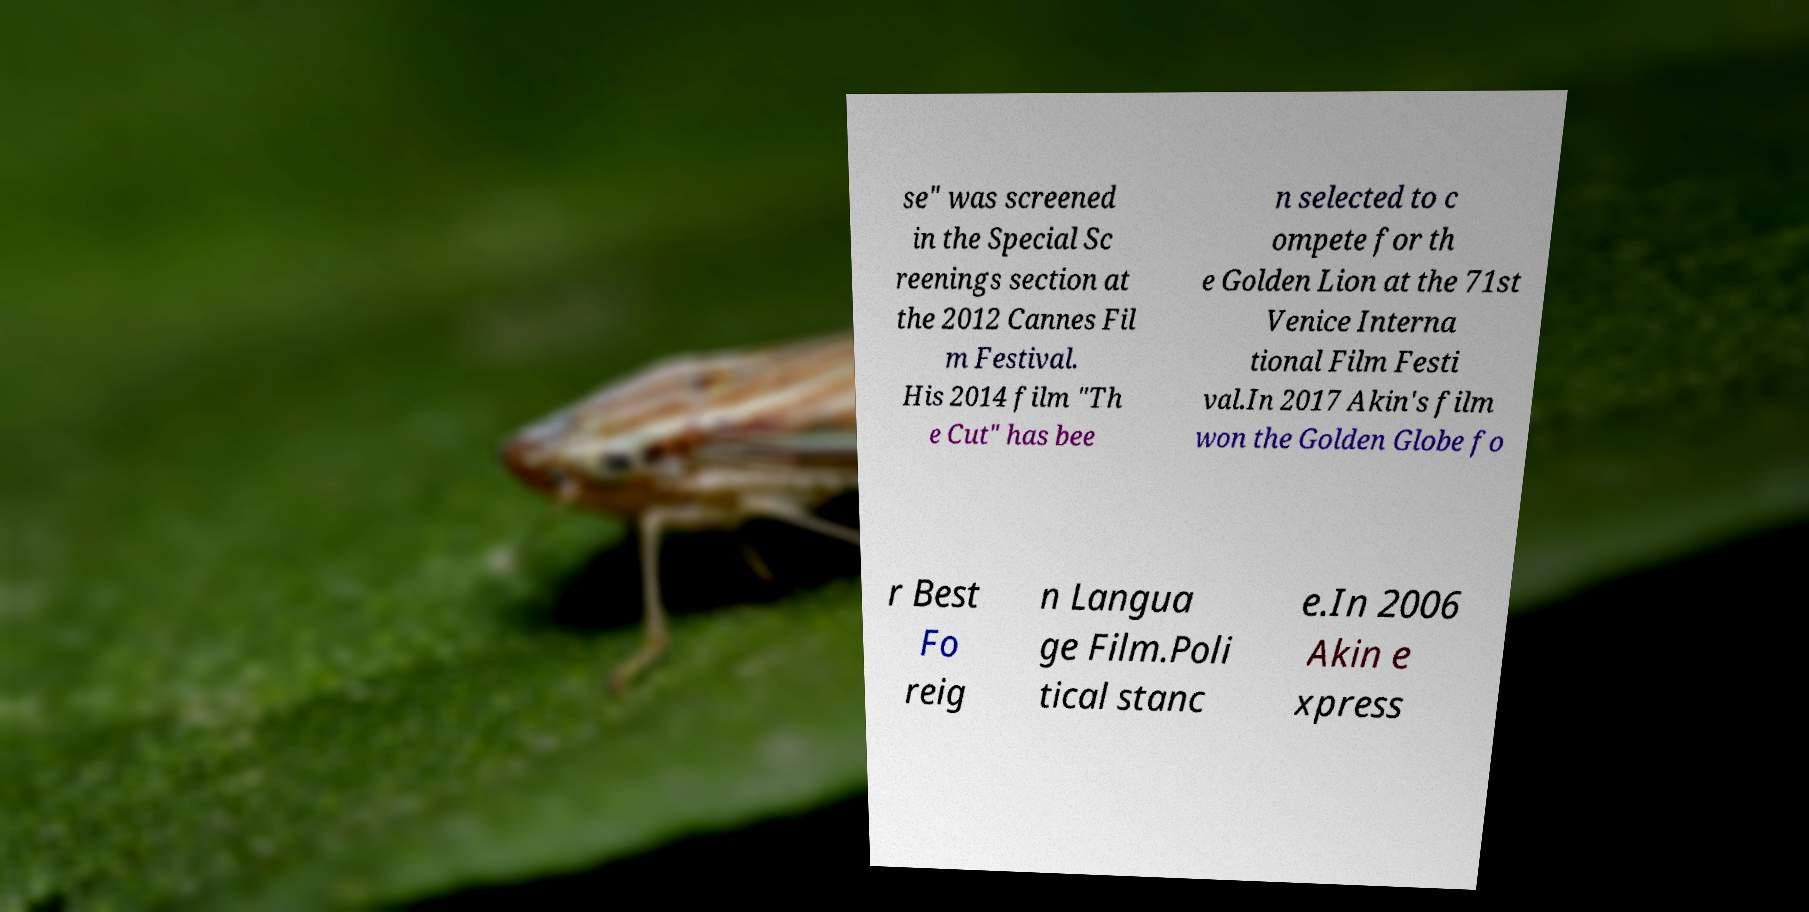Can you read and provide the text displayed in the image?This photo seems to have some interesting text. Can you extract and type it out for me? se" was screened in the Special Sc reenings section at the 2012 Cannes Fil m Festival. His 2014 film "Th e Cut" has bee n selected to c ompete for th e Golden Lion at the 71st Venice Interna tional Film Festi val.In 2017 Akin's film won the Golden Globe fo r Best Fo reig n Langua ge Film.Poli tical stanc e.In 2006 Akin e xpress 